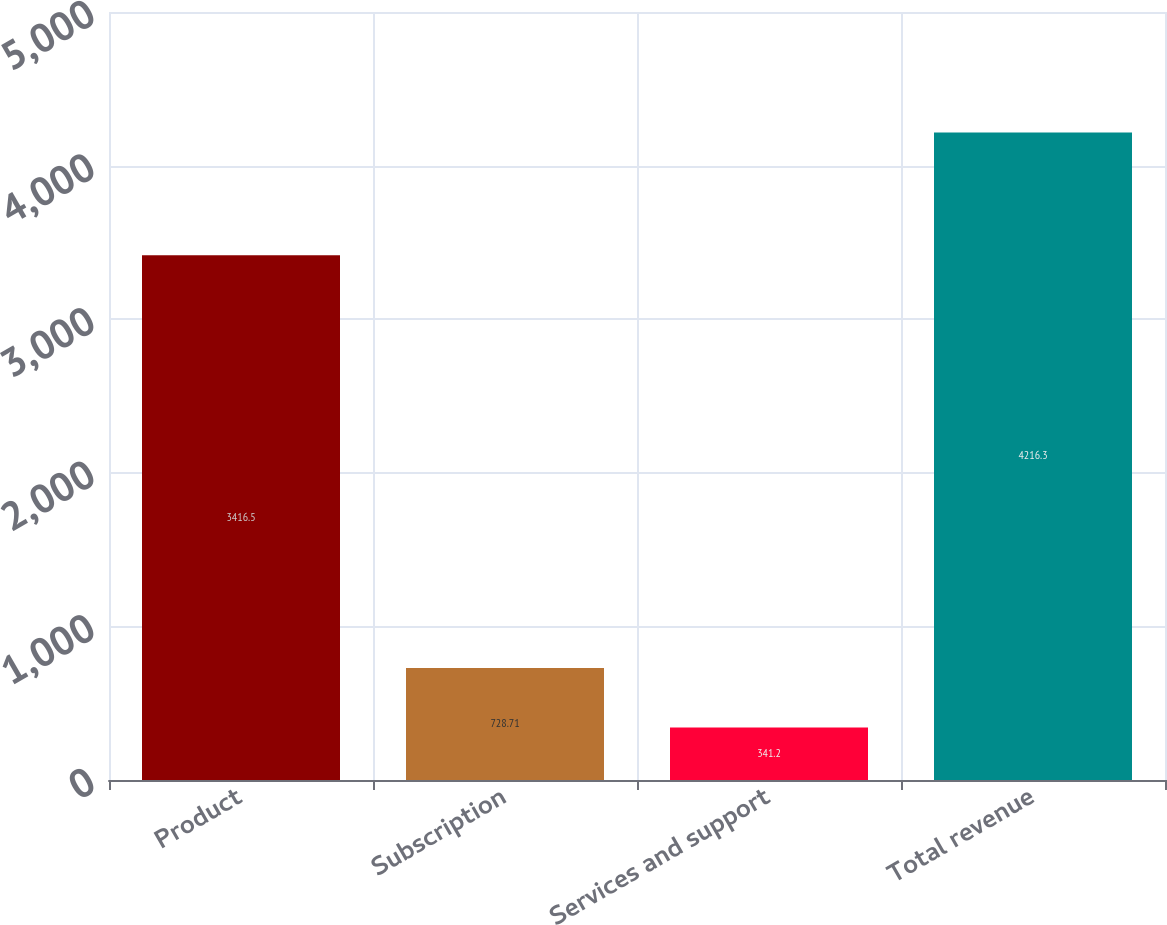Convert chart. <chart><loc_0><loc_0><loc_500><loc_500><bar_chart><fcel>Product<fcel>Subscription<fcel>Services and support<fcel>Total revenue<nl><fcel>3416.5<fcel>728.71<fcel>341.2<fcel>4216.3<nl></chart> 